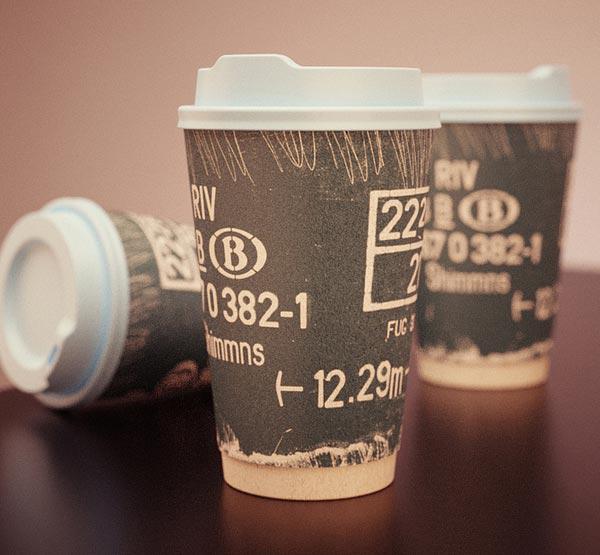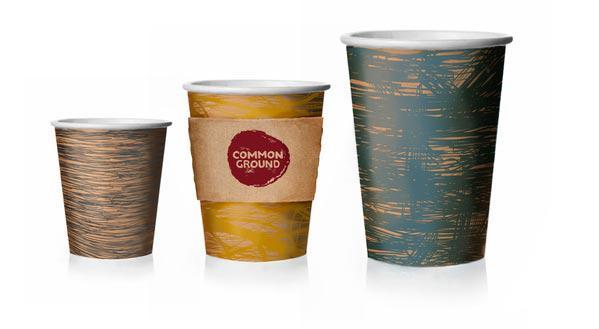The first image is the image on the left, the second image is the image on the right. Assess this claim about the two images: "There are exactly five cups.". Correct or not? Answer yes or no. No. The first image is the image on the left, the second image is the image on the right. Assess this claim about the two images: "There are five coffee cups.". Correct or not? Answer yes or no. No. 